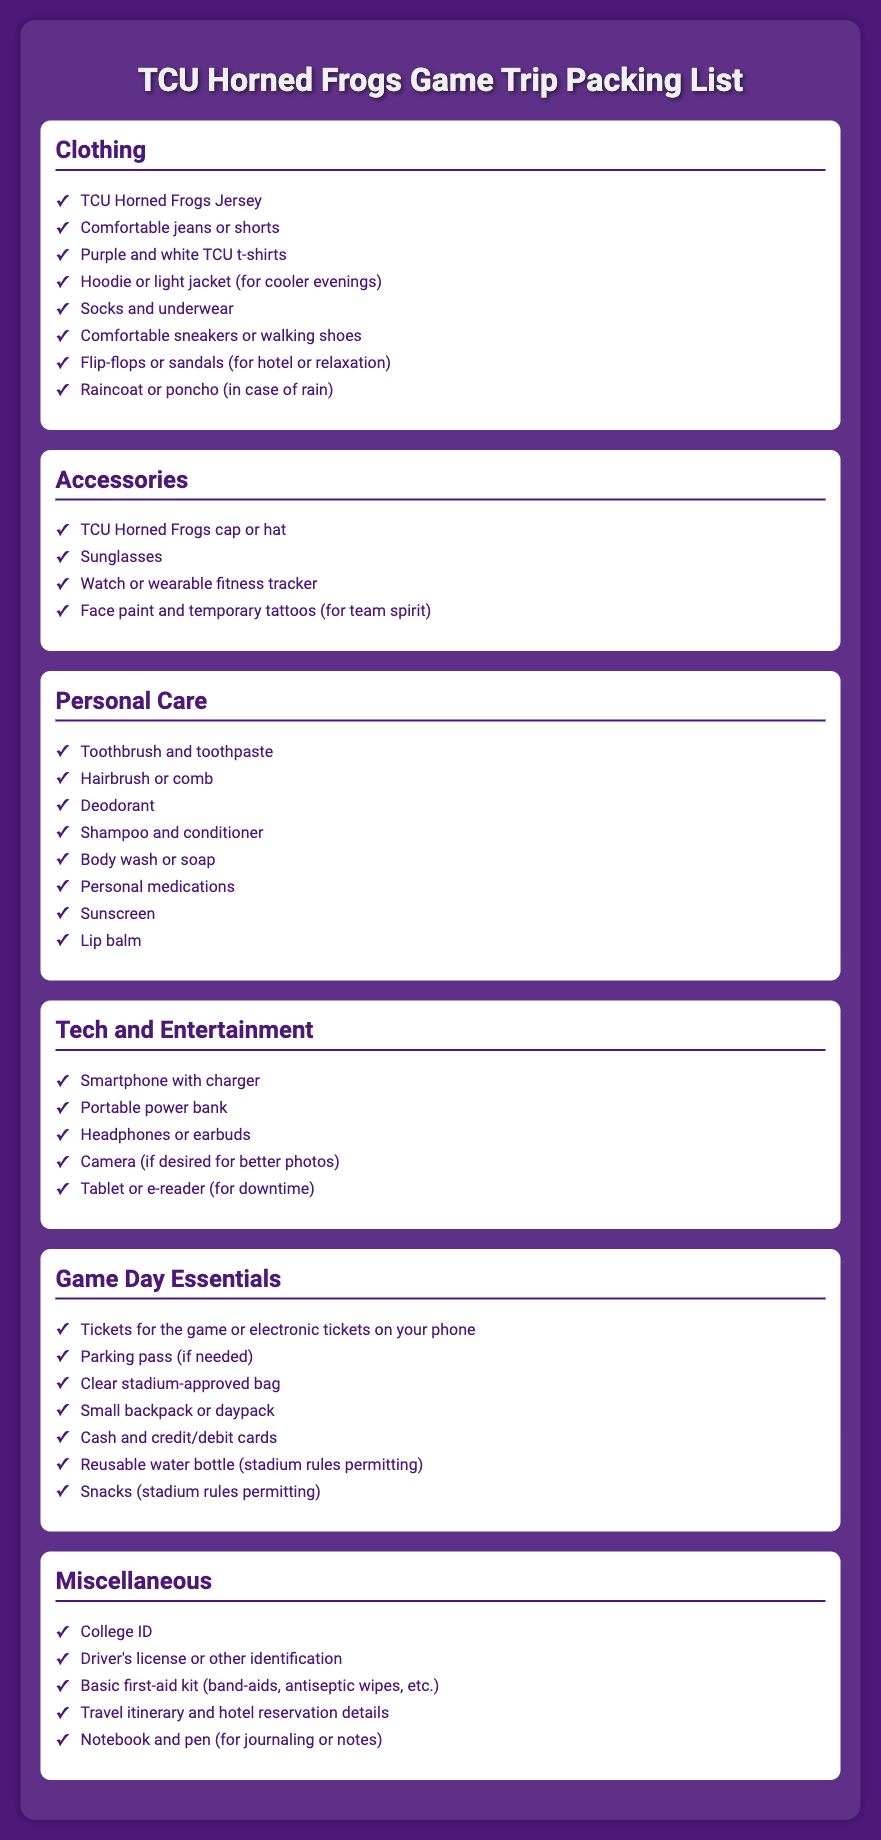What should I wear to the game? The clothing section lists items like TCU Horned Frogs Jersey, comfortable jeans or shorts, and purple and white TCU t-shirts as essential apparel for the game.
Answer: TCU Horned Frogs Jersey What personal care items are recommended? The personal care section includes items such as toothbrush and toothpaste, deodorant, and sunscreen that you should bring for personal hygiene.
Answer: Toothbrush and toothpaste How many types of accessories are listed? The accessories section has 4 types: cap or hat, sunglasses, watch or fitness tracker, and face paint or temporary tattoos.
Answer: 4 What tech gadget is suggested for downtime? The tech and entertainment section suggests bringing a tablet or e-reader for leisure time during the trip.
Answer: Tablet or e-reader What is one item you need for game day entry? The game day essentials section mentions that you need tickets for the game or electronic tickets on your phone to enter.
Answer: Tickets for the game What is included in the miscellaneous category? The miscellaneous section includes items like college ID and driver's license, which are necessary for personal identification during the trip.
Answer: College ID How many items are listed under Game Day Essentials? There are 7 items listed under the game day essentials category that are crucial for attending the game.
Answer: 7 What type of shoes should you pack? The clothing section recommends comfortable sneakers or walking shoes for the trip.
Answer: Comfortable sneakers or walking shoes 